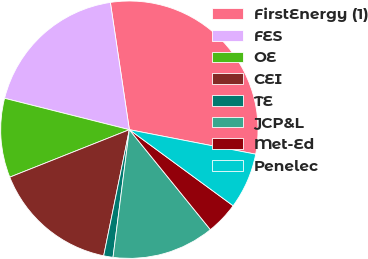Convert chart. <chart><loc_0><loc_0><loc_500><loc_500><pie_chart><fcel>FirstEnergy (1)<fcel>FES<fcel>OE<fcel>CEI<fcel>TE<fcel>JCP&L<fcel>Met-Ed<fcel>Penelec<nl><fcel>30.41%<fcel>18.72%<fcel>9.94%<fcel>15.79%<fcel>1.17%<fcel>12.87%<fcel>4.09%<fcel>7.02%<nl></chart> 